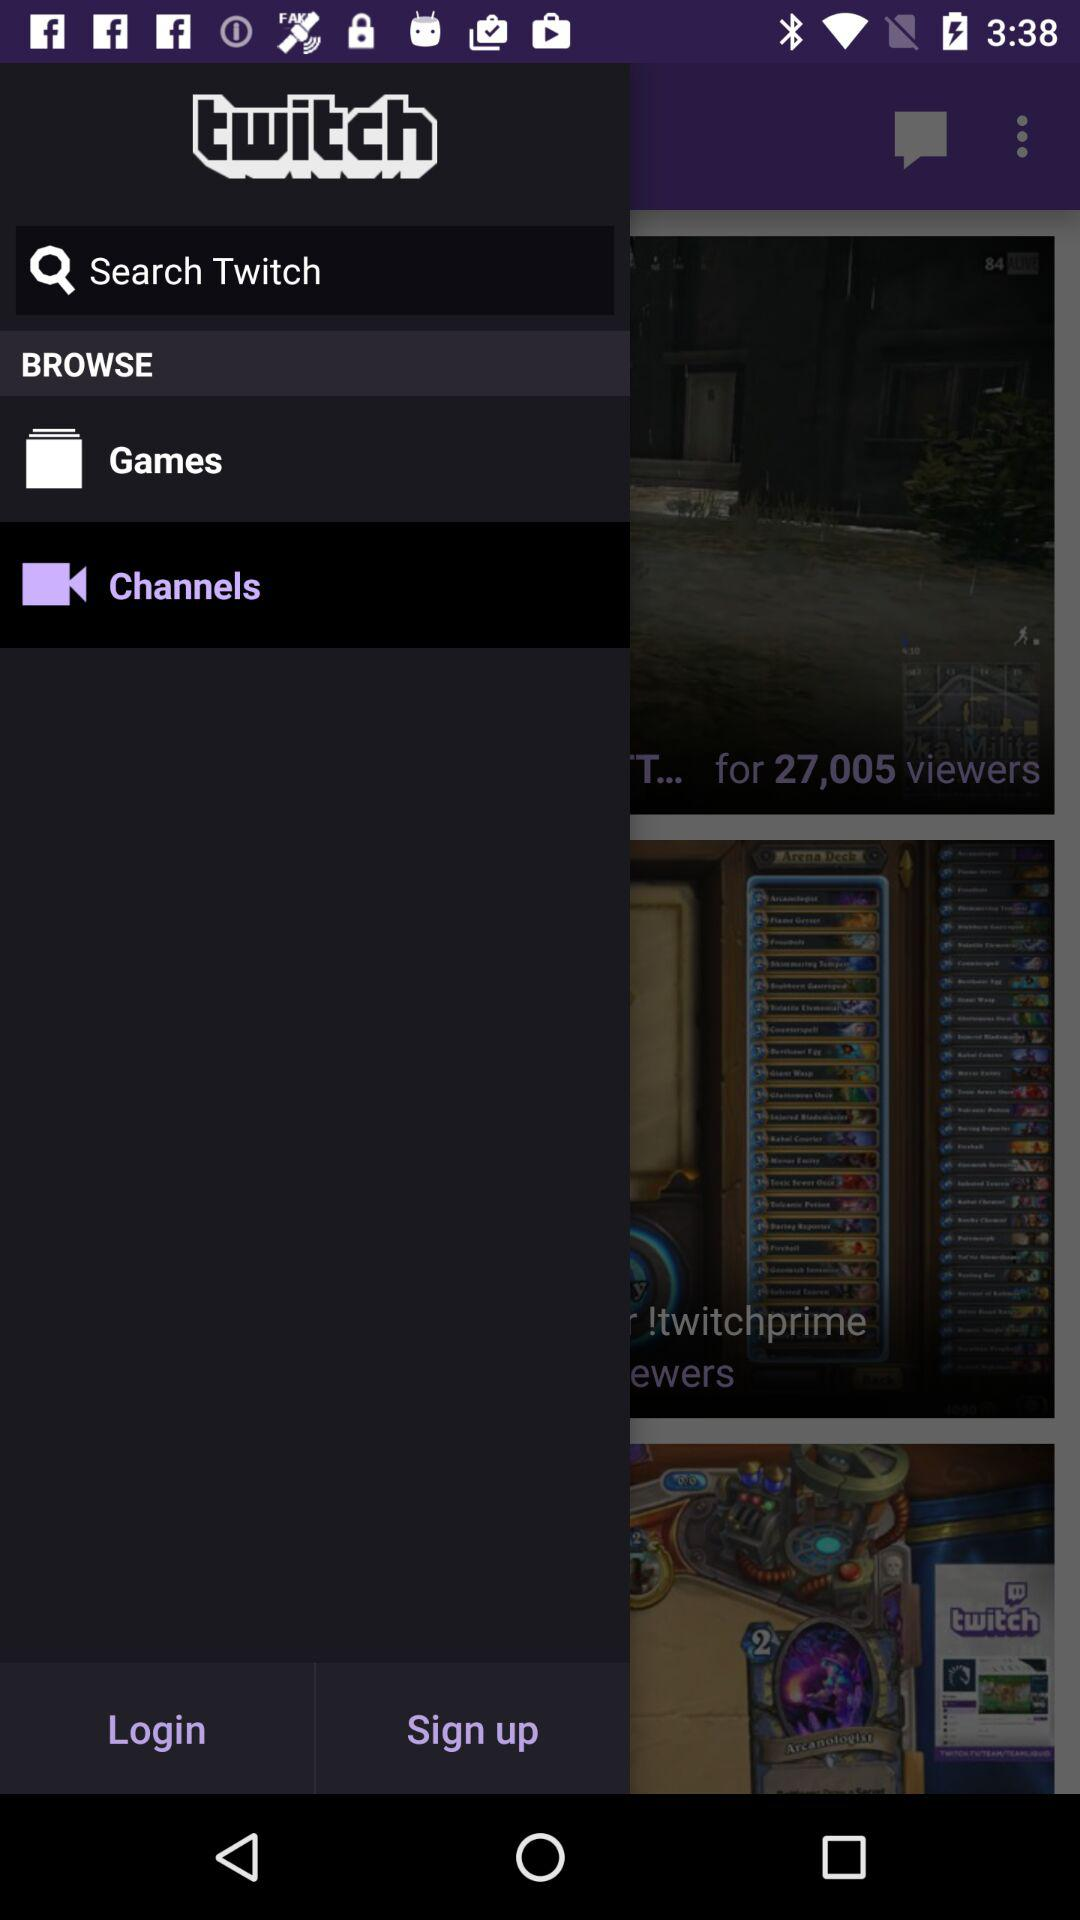How many viewers does the channel with the most viewers have?
Answer the question using a single word or phrase. 27,005 